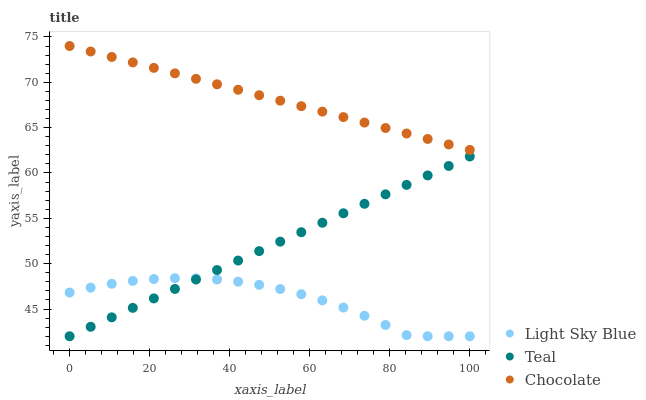Does Light Sky Blue have the minimum area under the curve?
Answer yes or no. Yes. Does Chocolate have the maximum area under the curve?
Answer yes or no. Yes. Does Teal have the minimum area under the curve?
Answer yes or no. No. Does Teal have the maximum area under the curve?
Answer yes or no. No. Is Teal the smoothest?
Answer yes or no. Yes. Is Light Sky Blue the roughest?
Answer yes or no. Yes. Is Chocolate the smoothest?
Answer yes or no. No. Is Chocolate the roughest?
Answer yes or no. No. Does Light Sky Blue have the lowest value?
Answer yes or no. Yes. Does Chocolate have the lowest value?
Answer yes or no. No. Does Chocolate have the highest value?
Answer yes or no. Yes. Does Teal have the highest value?
Answer yes or no. No. Is Teal less than Chocolate?
Answer yes or no. Yes. Is Chocolate greater than Light Sky Blue?
Answer yes or no. Yes. Does Light Sky Blue intersect Teal?
Answer yes or no. Yes. Is Light Sky Blue less than Teal?
Answer yes or no. No. Is Light Sky Blue greater than Teal?
Answer yes or no. No. Does Teal intersect Chocolate?
Answer yes or no. No. 